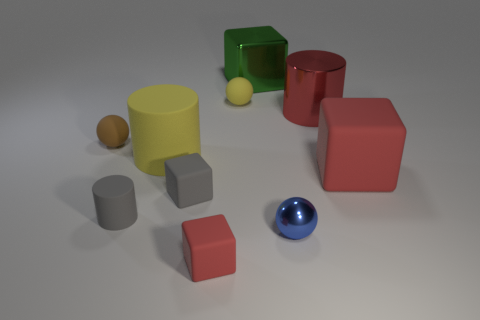What is the size of the rubber block that is behind the blue metal sphere and in front of the big red matte object?
Make the answer very short. Small. What number of other objects are there of the same shape as the large green shiny thing?
Provide a succinct answer. 3. How many tiny matte things are behind the big yellow matte cylinder?
Offer a terse response. 2. Are there fewer green objects right of the large red matte block than red matte cubes to the right of the yellow cylinder?
Offer a very short reply. Yes. What shape is the red object on the left side of the yellow rubber thing to the right of the large rubber thing that is to the left of the tiny shiny thing?
Your answer should be compact. Cube. The tiny object that is both in front of the small gray cylinder and to the left of the blue sphere has what shape?
Your answer should be very brief. Cube. Is there another large yellow thing made of the same material as the large yellow object?
Offer a terse response. No. There is a sphere that is the same color as the large matte cylinder; what size is it?
Ensure brevity in your answer.  Small. There is a large block that is to the left of the large red block; what is its color?
Your response must be concise. Green. There is a large red metallic thing; is its shape the same as the red rubber object that is in front of the big red rubber block?
Make the answer very short. No. 